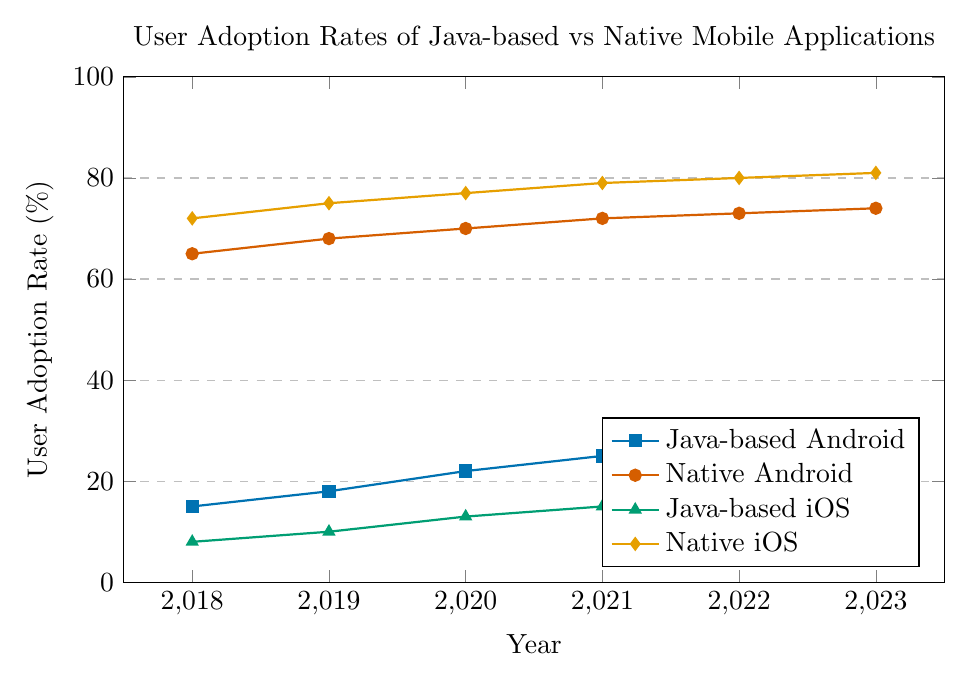What is the general trend for user adoption rates of Java-based Android applications from 2018 to 2023? From 2018 to 2023, the user adoption rate for Java-based Android applications increases steadily each year.
Answer: Increasing In 2021, which type of application has a higher user adoption rate: Java-based iOS or Native Android? Compare the values in 2021 for Java-based iOS (15%) and Native Android (72%). The Native Android rate is higher.
Answer: Native Android What is the difference in user adoption rates between Native iOS and Java-based iOS in 2020? In 2020, the user adoption rates are 77% for Native iOS and 13% for Java-based iOS. Subtract 13% from 77% to find the difference.
Answer: 64% Which type of application shows the smallest increase in user adoption rates from 2018 to 2023? Calculate the increases for each application type by subtracting 2018 values from 2023 values: Java-based Android (15%), Native Android (9%), Java-based iOS (12%), Native iOS (9%). The smallest increase is for Native Android and Native iOS.
Answer: Native Android and Native iOS In what year do Native Android and Native iOS applications have their lowest user adoption rates throughout the period? Look at the adoption rates for Native Android and Native iOS from 2018 to 2023. The lowest rates for both are in 2018.
Answer: 2018 What is the average user adoption rate for Java-based Android applications over the years 2018 to 2023? Add the user adoption rates for each year: 15 + 18 + 22 + 25 + 28 + 30 = 138. Divide by the number of years (6).
Answer: 23% How does the user adoption rate of Java-based iOS in 2022 compare to Java-based Android in 2019? The user adoption rate for Java-based iOS in 2022 is 18%, and for Java-based Android in 2019 is 18%. Both rates are equal.
Answer: Equal Which year shows the maximum user adoption rate for Native iOS applications? Check the user adoption rates for Native iOS from 2018 to 2023. The maximum rate is in 2023 with 81%.
Answer: 2023 By how many percentage points did the user adoption rate for Java-based Android applications increase from 2021 to 2023? Subtract the 2021 rate (25%) from the 2023 rate (30%).
Answer: 5% In which year do the user adoption rates for Java-based applications (both Android and iOS) show the same increasing pattern, with both rates increasing compared to the previous year? Check the trends for Java-based Android and Java-based iOS for all years. The rates increase every year, so the same pattern is present every year from 2018 to 2023.
Answer: 2018 to 2023 